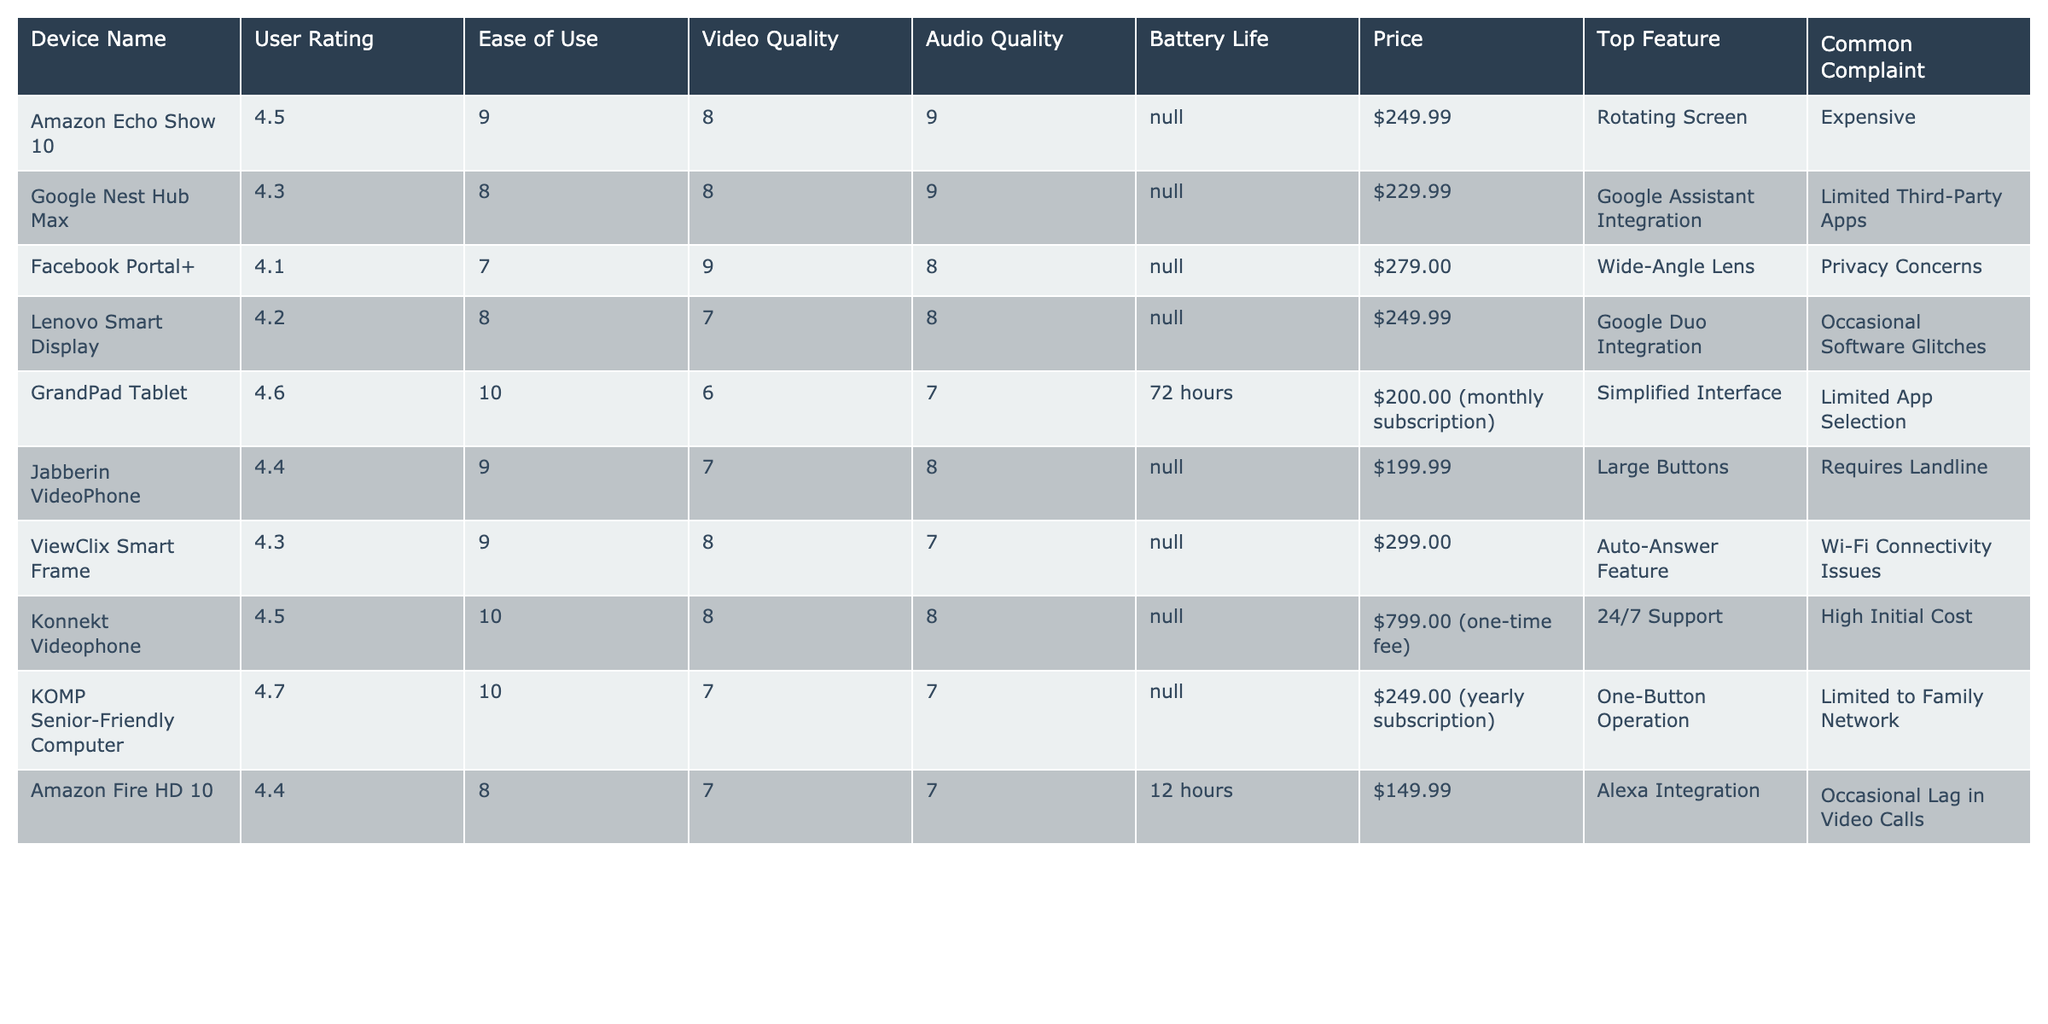What is the user rating for the Google Nest Hub Max? The user rating for the Google Nest Hub Max can be found directly in the table under the "User Rating" column, which shows a rating of 4.3.
Answer: 4.3 Which device has the highest ease of use rating? Looking at the "Ease of Use" column, the GrandPad Tablet has an ease of use rating of 10, which is the highest among all devices listed in the table.
Answer: GrandPad Tablet What is the price of the Facebook Portal+? The price of the Facebook Portal+ can be found in the "Price" column, which lists it as $279.00.
Answer: $279.00 Is the Amazon Echo Show 10 cheaper than the Google Nest Hub Max? By comparing the prices in the "Price" column, the Amazon Echo Show 10 is priced at $249.99 while the Google Nest Hub Max is priced at $229.99. Since $249.99 is greater than $229.99, the statement is false.
Answer: No What is the average user rating of all devices listed? To find the average user rating, add up all individual ratings: 4.5 + 4.3 + 4.1 + 4.2 + 4.6 + 4.4 + 4.3 + 4.5 + 4.7 + 4.4 = 44.0. There are 10 devices, so the average is 44.0 / 10 = 4.4.
Answer: 4.4 Which device has the longest battery life? The table shows that the GrandPad Tablet has a battery life of 72 hours, which is longer than the other devices listed, as they either have no battery information or fewer hours.
Answer: GrandPad Tablet What is a common complaint regarding the KOMP Senior-Friendly Computer? The common complaint for the KOMP Senior-Friendly Computer is that it is limited to family network use, which can be found in the "Common Complaint" column.
Answer: Limited to Family Network Do any devices listed have a top feature related to video integration? Yes, the devices that have a top feature related to video integration are the Facebook Portal+ with its wide-angle lens, and the Lenovo Smart Display with Google Duo integration. Both features enhance video calling experiences.
Answer: Yes Which device offers a rotating screen as a top feature? According to the "Top Feature" column, the Amazon Echo Show 10 offers a rotating screen.
Answer: Amazon Echo Show 10 What is the difference in price between the Konnekt Videophone and the Jabberin VideoPhone? The price of the Konnekt Videophone is $799.00 while the Jabberin VideoPhone is $199.99. The difference is calculated as $799.00 - $199.99 = $599.01.
Answer: $599.01 Which device has the lowest audio quality rating? The device with the lowest audio quality rating in the "Audio Quality" column is the GrandPad Tablet, which has a rating of 7.
Answer: GrandPad Tablet 